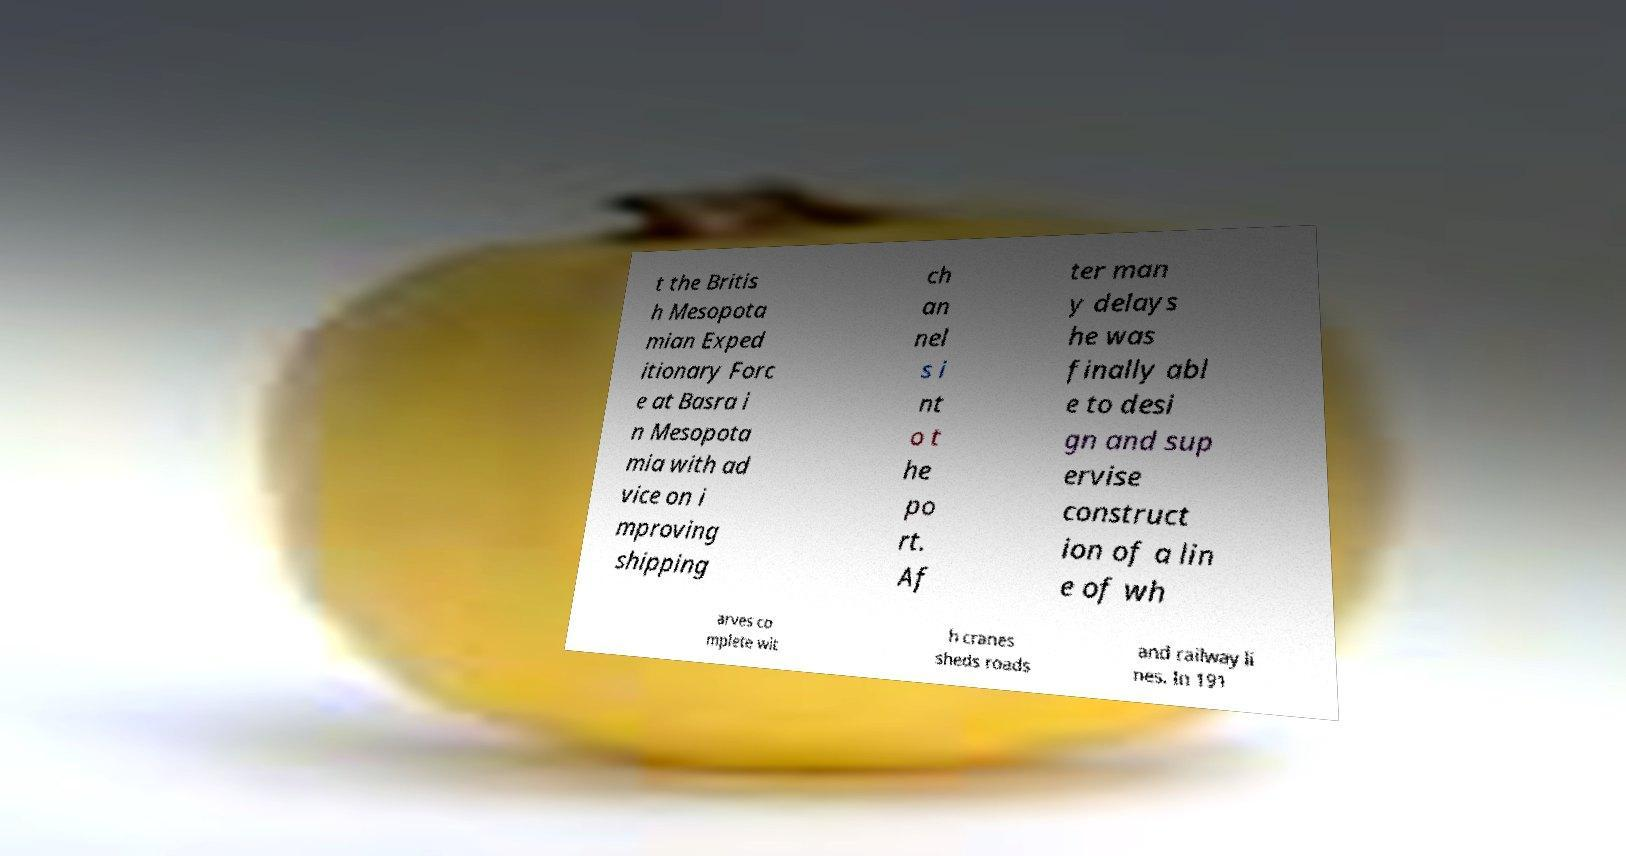Can you read and provide the text displayed in the image?This photo seems to have some interesting text. Can you extract and type it out for me? t the Britis h Mesopota mian Exped itionary Forc e at Basra i n Mesopota mia with ad vice on i mproving shipping ch an nel s i nt o t he po rt. Af ter man y delays he was finally abl e to desi gn and sup ervise construct ion of a lin e of wh arves co mplete wit h cranes sheds roads and railway li nes. In 191 